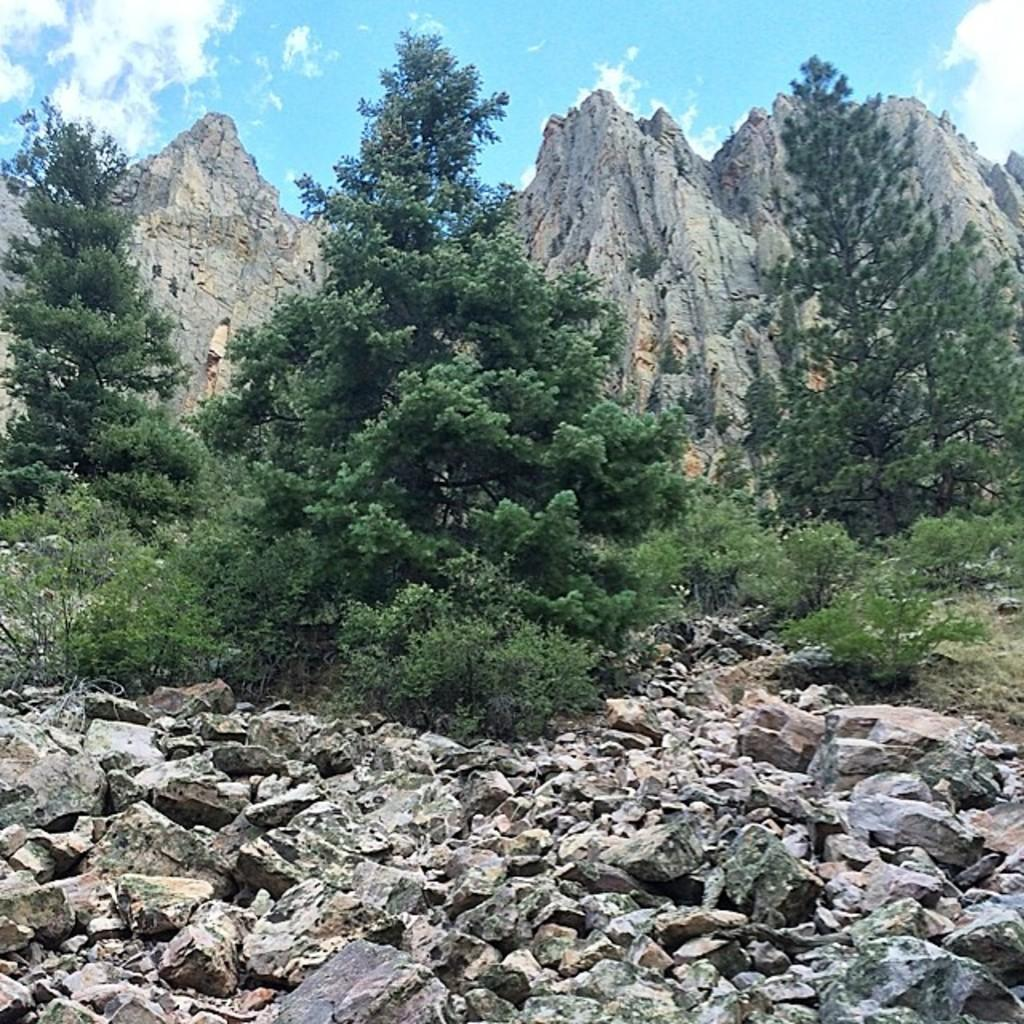What is on the ground in the image? There are stones on the ground in the image. What can be seen in the background of the image? There are trees and mountains in the background of the image. How would you describe the sky in the image? The sky is blue and cloudy in the image. What news is being reported by the cows in the image? There are no cows present in the image, so there is no news being reported. What scent can be detected from the stones in the image? The image does not provide any information about the scent of the stones, so it cannot be determined from the image. 